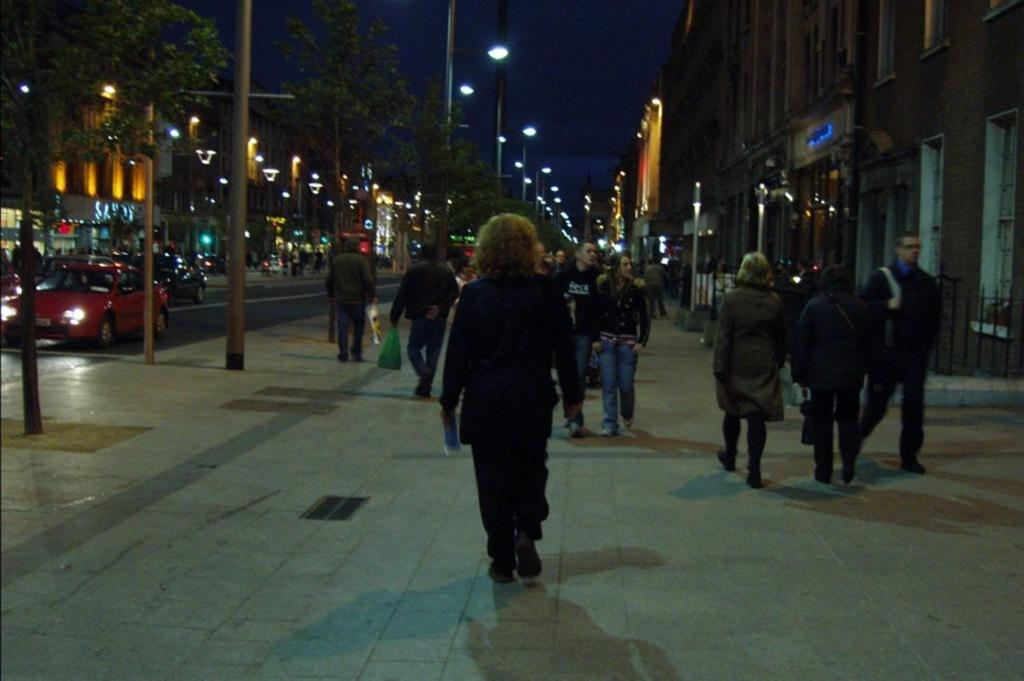What is happening in the image? There is a group of people standing in the image. What else can be seen on the road in the image? There are vehicles on the road in the image. What type of structure can be seen in the image? There are iron grilles in the image. What objects are present in the image that provide illumination? There are lights in the image. What are the tall, slender objects in the image? There are poles in the image. What type of vegetation is present in the image? There are trees in the image. What type of man-made structures can be seen in the image? There are buildings in the image. What can be seen in the background of the image? The sky is visible in the background of the image. Can you tell me how many tigers are hiding in the trees in the image? There are no tigers present in the image; it features trees and buildings. What type of committee is meeting in the image? There is no committee meeting in the image; it shows a group of people standing, vehicles on the road, and other elements. 